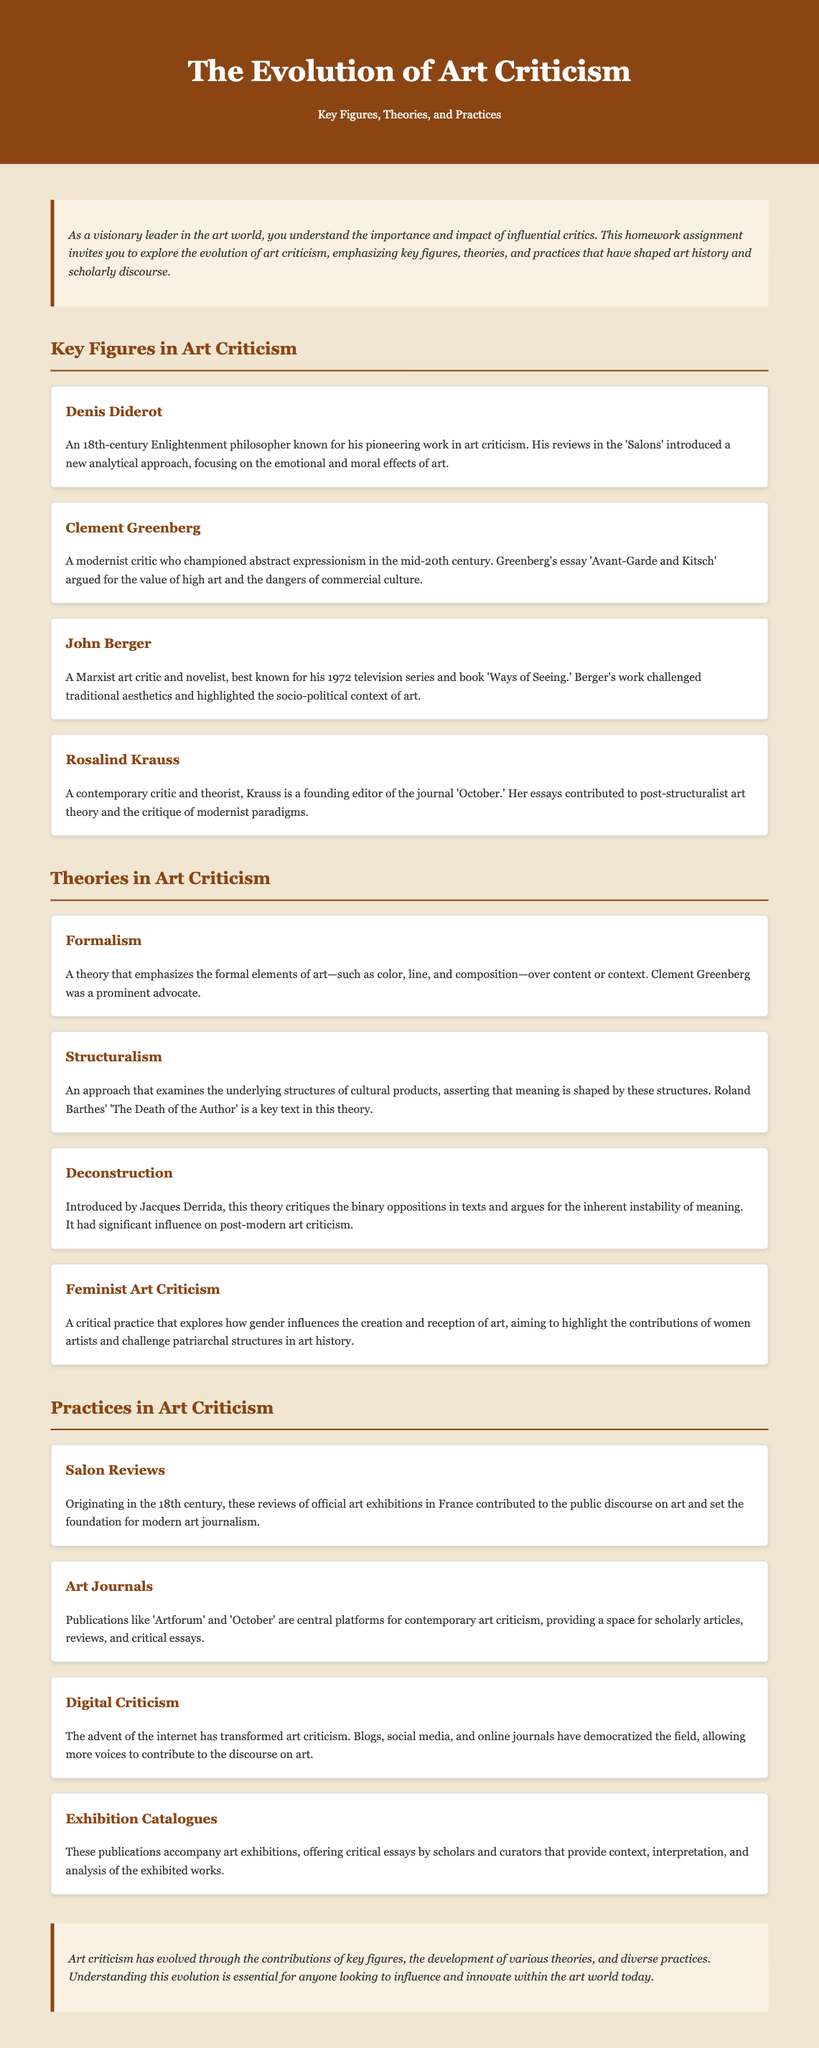What is the title of the homework assignment? The title of the homework assignment is found in the header of the document.
Answer: The Evolution of Art Criticism: Key Figures, Theories, and Practices Who is known for the essay 'Avant-Garde and Kitsch'? The document lists Clement Greenberg as the critic associated with this essay.
Answer: Clement Greenberg What critical theory emphasizes formal elements of art? The document specifies that Formalism advocates for the importance of formal elements in art.
Answer: Formalism Which critic is recognized for the book 'Ways of Seeing'? John Berger is noted for this work in the document.
Answer: John Berger What practice originated in the 18th century that reviews art exhibitions? The document explains that Salon Reviews started in the 18th century.
Answer: Salon Reviews How many key figures in art criticism are highlighted in the document? The document lists a total of four key figures in the section mentioned.
Answer: Four What is a major platform for contemporary art criticism mentioned? The document mentions 'Artforum' as a key publication in this area.
Answer: Artforum Which theory introduced by Jacques Derrida critiques binary oppositions? The document states that Deconstruction is the theory introduced by Derrida.
Answer: Deconstruction What type of criticism has been transformed by the internet? The document describes Digital Criticism as being affected by the internet.
Answer: Digital Criticism 